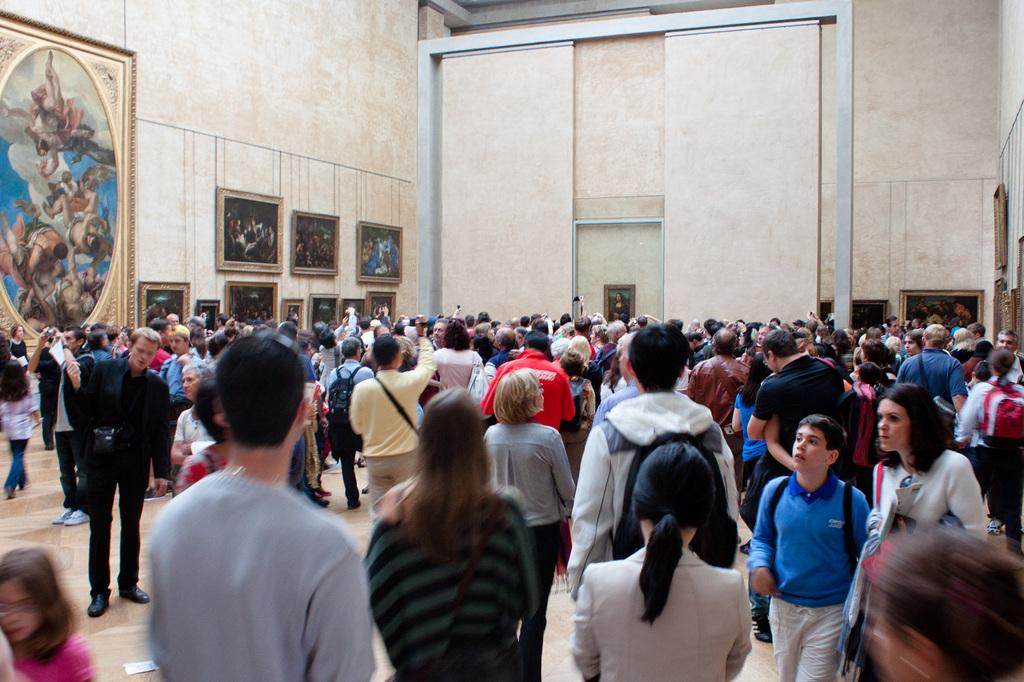How many people are in the image? There are persons in the image, but the exact number is not specified. What can be seen on the wall in the image? There are frames on the wall in the image. Is there any snow visible in the image? There is no mention of snow in the provided facts, so it cannot be determined if snow is present in the image. 